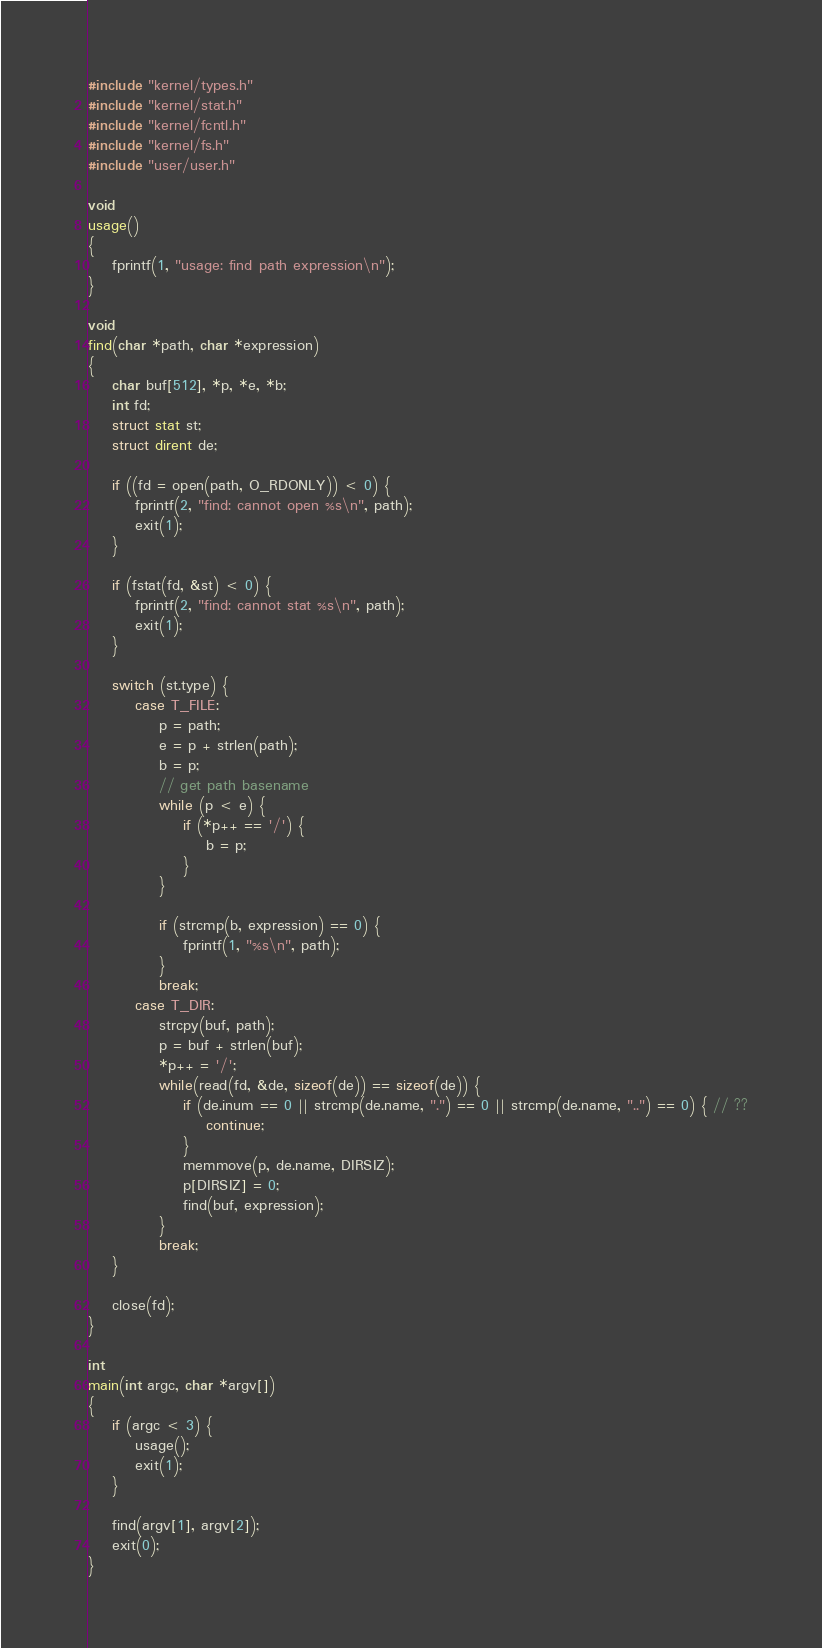<code> <loc_0><loc_0><loc_500><loc_500><_C_>#include "kernel/types.h"
#include "kernel/stat.h"
#include "kernel/fcntl.h"
#include "kernel/fs.h"
#include "user/user.h"

void
usage()
{
    fprintf(1, "usage: find path expression\n");
}

void
find(char *path, char *expression)
{
    char buf[512], *p, *e, *b;
    int fd;
    struct stat st;
    struct dirent de;

    if ((fd = open(path, O_RDONLY)) < 0) {
        fprintf(2, "find: cannot open %s\n", path);
        exit(1);
    }

    if (fstat(fd, &st) < 0) {
        fprintf(2, "find: cannot stat %s\n", path);
        exit(1);
    }

    switch (st.type) {
        case T_FILE:
            p = path;
            e = p + strlen(path);
            b = p;
            // get path basename
            while (p < e) {
                if (*p++ == '/') {
                    b = p;
                }
            }

            if (strcmp(b, expression) == 0) {
                fprintf(1, "%s\n", path);
            }
            break;
        case T_DIR:
            strcpy(buf, path);
            p = buf + strlen(buf);
            *p++ = '/';
            while(read(fd, &de, sizeof(de)) == sizeof(de)) {
                if (de.inum == 0 || strcmp(de.name, ".") == 0 || strcmp(de.name, "..") == 0) { // ??
                    continue;
                }
                memmove(p, de.name, DIRSIZ);
                p[DIRSIZ] = 0;
                find(buf, expression);
            }
            break;
    }

    close(fd);
}

int
main(int argc, char *argv[])
{
    if (argc < 3) {
        usage();
        exit(1);
    }

    find(argv[1], argv[2]);
    exit(0);
}
</code> 